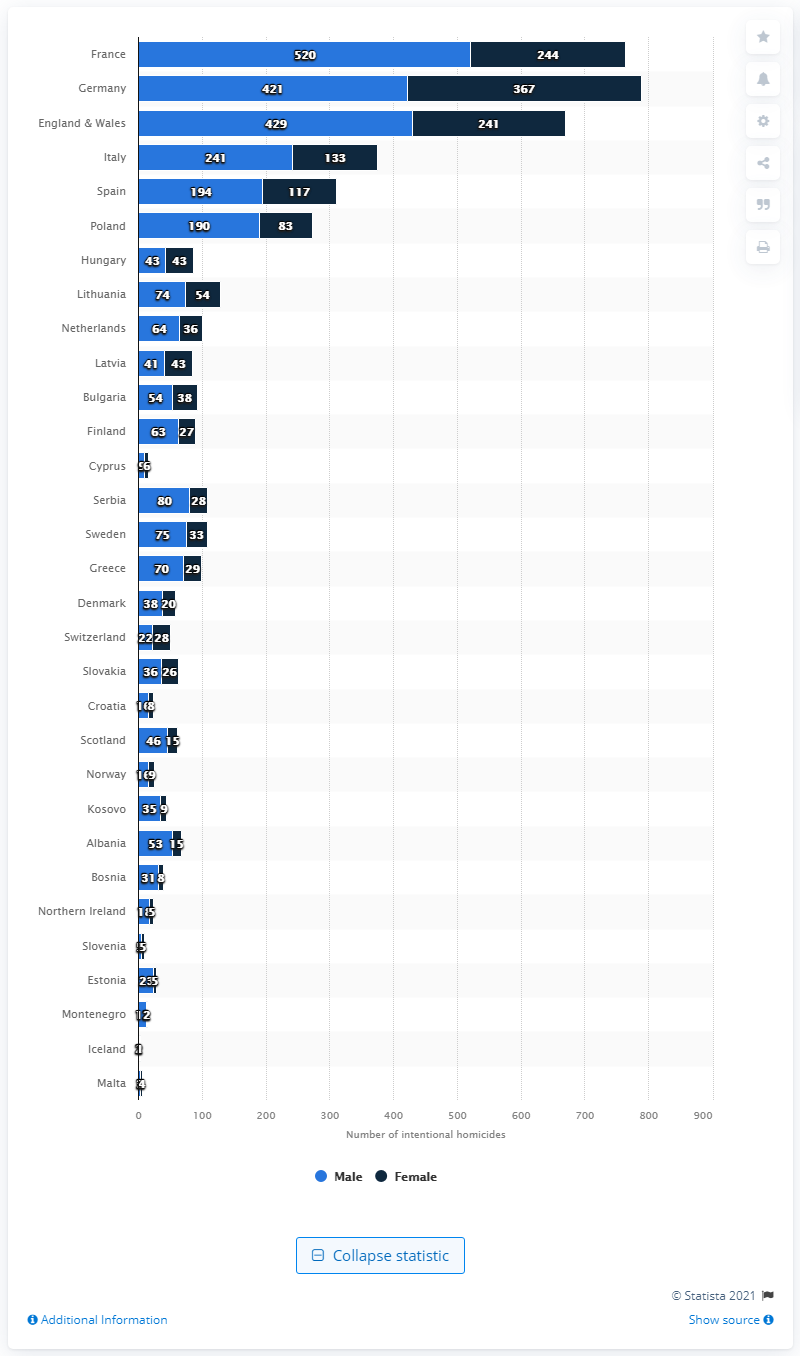Identify some key points in this picture. In 2018, France had the second highest number of intentional homicides. In 2018, 367 of the victims in Germany were female. In 2018, Germany had the highest number of overall homicides among all countries in Europe. 